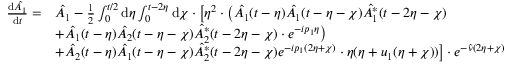<formula> <loc_0><loc_0><loc_500><loc_500>\begin{array} { r l } { \frac { d \hat { A _ { 1 } } } { d t } = } & { \hat { A _ { 1 } } - \frac { 1 } { 2 } \int _ { 0 } ^ { t / 2 } d \eta \int _ { 0 } ^ { t - 2 \eta } d \chi \cdot \left [ \eta ^ { 2 } \cdot \left ( \hat { A _ { 1 } } ( t - \eta ) \hat { A _ { 1 } } ( t - \eta - \chi ) \hat { A _ { 1 } ^ { * } } ( t - 2 \eta - \chi ) } \\ & { + \hat { A _ { 1 } } ( t - \eta ) \hat { A _ { 2 } } ( t - \eta - \chi ) \hat { A _ { 2 } ^ { * } } ( t - 2 \eta - \chi ) \cdot e ^ { - i p _ { 1 } \eta } \right ) } \\ & { + \hat { A _ { 2 } } ( t - \eta ) \hat { A _ { 1 } } ( t - \eta - \chi ) \hat { A _ { 2 } ^ { * } } ( t - 2 \eta - \chi ) e ^ { - i p _ { 1 } ( 2 \eta + \chi ) } \cdot \eta ( \eta + u _ { 1 } ( \eta + \chi ) ) \right ] \cdot e ^ { - \hat { \nu } ( 2 \eta + \chi ) } } \end{array}</formula> 